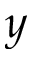<formula> <loc_0><loc_0><loc_500><loc_500>y</formula> 